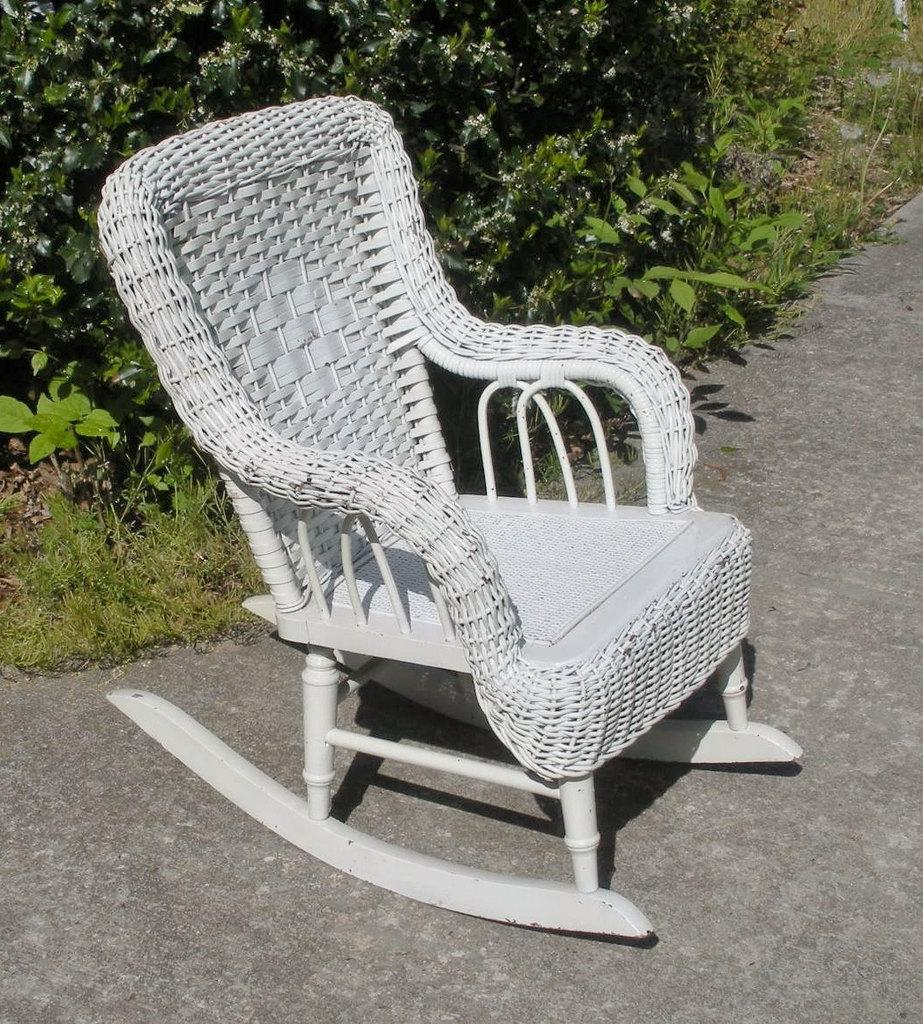What type of chair is in the image? There is a white color chair in the image. What else can be seen in the image besides the chair? There are many plants in the image. What type of linen is draped over the scarecrow in the image? There is no scarecrow present in the image, so it is not possible to answer that question. 